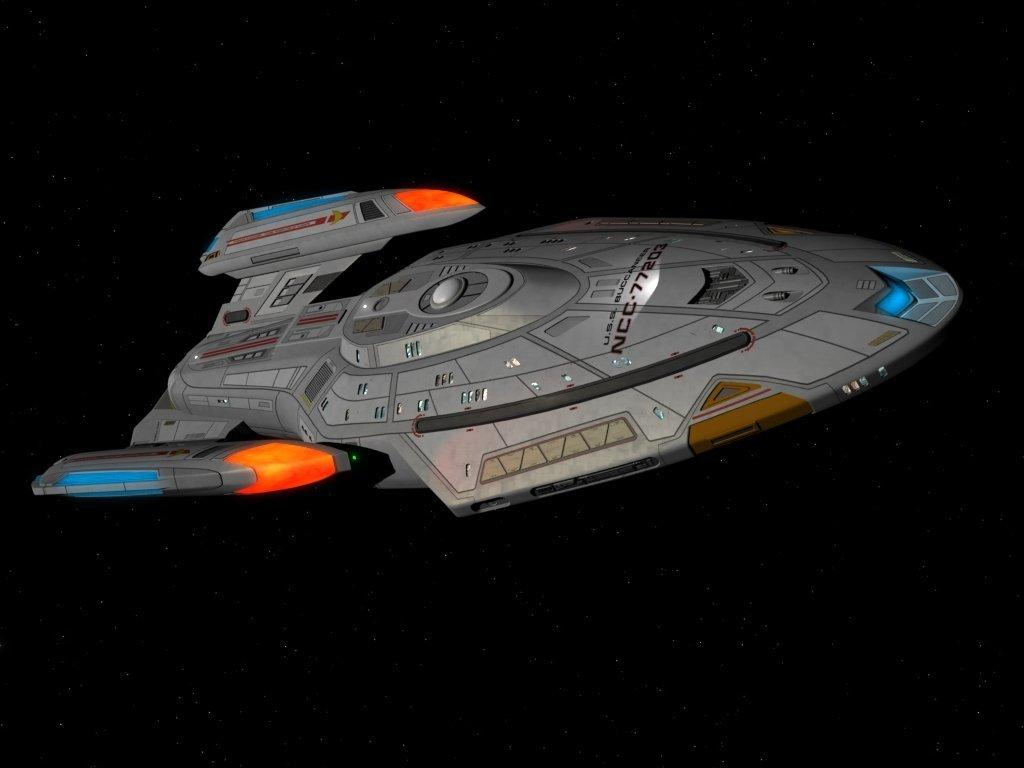What is the main subject of the image? The main subject of the image is a spaceship. Can you describe the background of the image? The background of the image is dark. What type of polish is being applied to the baseball in the image? There is no baseball or polish present in the image; it features a spaceship with a dark background. 